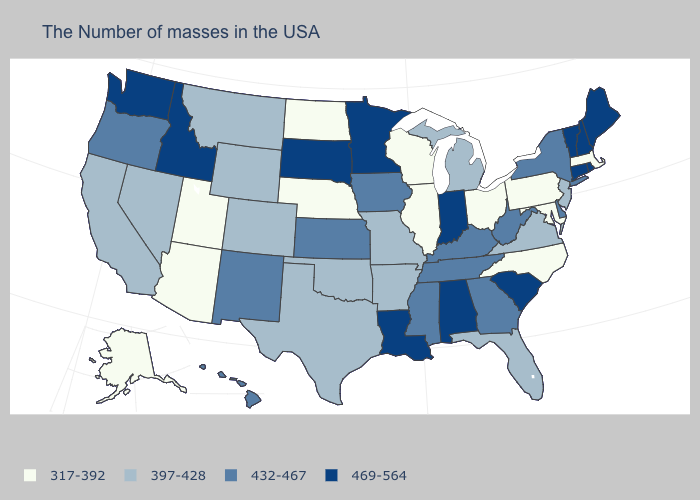Which states have the highest value in the USA?
Concise answer only. Maine, Rhode Island, New Hampshire, Vermont, Connecticut, South Carolina, Indiana, Alabama, Louisiana, Minnesota, South Dakota, Idaho, Washington. Name the states that have a value in the range 317-392?
Short answer required. Massachusetts, Maryland, Pennsylvania, North Carolina, Ohio, Wisconsin, Illinois, Nebraska, North Dakota, Utah, Arizona, Alaska. Name the states that have a value in the range 432-467?
Give a very brief answer. New York, Delaware, West Virginia, Georgia, Kentucky, Tennessee, Mississippi, Iowa, Kansas, New Mexico, Oregon, Hawaii. What is the value of Wisconsin?
Answer briefly. 317-392. What is the value of Alabama?
Answer briefly. 469-564. What is the value of Maine?
Write a very short answer. 469-564. Does North Carolina have the lowest value in the South?
Quick response, please. Yes. Does Washington have the highest value in the West?
Answer briefly. Yes. What is the value of Massachusetts?
Answer briefly. 317-392. Does Colorado have the lowest value in the USA?
Be succinct. No. Name the states that have a value in the range 397-428?
Keep it brief. New Jersey, Virginia, Florida, Michigan, Missouri, Arkansas, Oklahoma, Texas, Wyoming, Colorado, Montana, Nevada, California. Name the states that have a value in the range 432-467?
Give a very brief answer. New York, Delaware, West Virginia, Georgia, Kentucky, Tennessee, Mississippi, Iowa, Kansas, New Mexico, Oregon, Hawaii. Name the states that have a value in the range 469-564?
Give a very brief answer. Maine, Rhode Island, New Hampshire, Vermont, Connecticut, South Carolina, Indiana, Alabama, Louisiana, Minnesota, South Dakota, Idaho, Washington. What is the value of Arizona?
Answer briefly. 317-392. Does Missouri have a higher value than Texas?
Write a very short answer. No. 